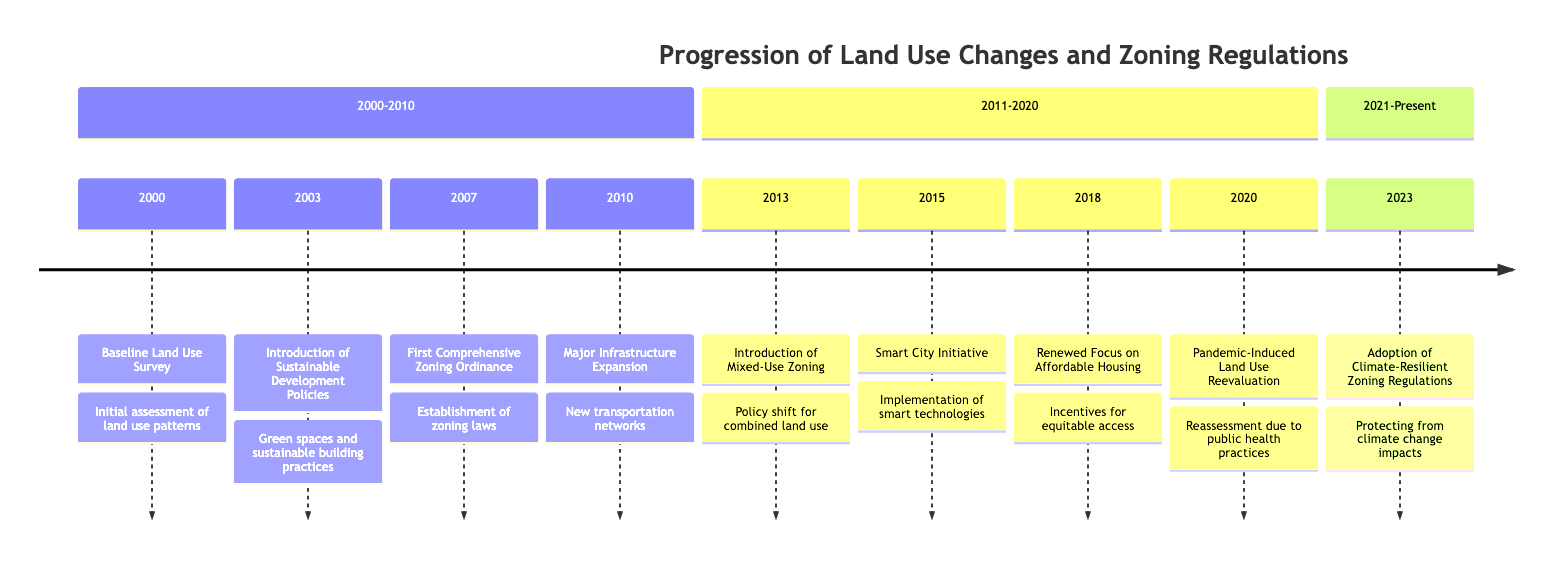What year was the Baseline Land Use Survey conducted? The timeline indicates that the Baseline Land Use Survey took place in the year 2000, as noted in the first entry of the timeline.
Answer: 2000 How many significant events are listed in the timeline from 2000 to 2010? By counting the events between the years 2000 to 2010 on the timeline, there are four significant events: Baseline Land Use Survey, Introduction of Sustainable Development Policies, First Comprehensive Zoning Ordinance, and Major Infrastructure Expansion.
Answer: 4 What type of zoning was introduced in 2013? The timeline specifies that in 2013, there was an Introduction of Mixed-Use Zoning, allowing for a combination of uses in developments.
Answer: Mixed-Use Zoning What major theme is present in the 2023 event? The event in 2023 is centered on the Adoption of Climate-Resilient Zoning Regulations, which indicates a focus on climate change impacts.
Answer: Climate-Resilient In which year did the Smart City Initiative begin? The timeline shows that the Smart City Initiative was implemented in the year 2015, as noted in the corresponding entry.
Answer: 2015 Compare the years of the Major Infrastructure Expansion and the Introduction of Mixed-Use Zoning. Which event occurred first? The Major Infrastructure Expansion took place in 2010, while the Introduction of Mixed-Use Zoning occurred in 2013. Since 2010 precedes 2013, the Major Infrastructure Expansion happened first.
Answer: Major Infrastructure Expansion How has the city's approach to land use changed from 2000 to 2020 based on the timeline? The timeline exhibits a shift in land use policies over the years, starting from a baseline survey in 2000, moving through sustainable development and comprehensive zoning in the earlier years, to a reevaluation of land use due to a pandemic in 2020, reflecting adaptability and evolving priorities in urban planning.
Answer: Evolving priorities Which section contains the event related to the Renewed Focus on Affordable Housing? The Renewed Focus on Affordable Housing appears in the section that covers the years from 2011 to 2020. This can be confirmed by locating the 2018 entry in that range.
Answer: 2011-2020 